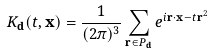<formula> <loc_0><loc_0><loc_500><loc_500>K _ { \mathbf d } ( t , { \mathbf x } ) = \frac { 1 } { ( 2 \pi ) ^ { 3 } } \sum _ { { \mathbf r } \in P _ { \mathbf d } } e ^ { i { \mathbf r } \cdot { \mathbf x } - t { \mathbf r } ^ { 2 } }</formula> 